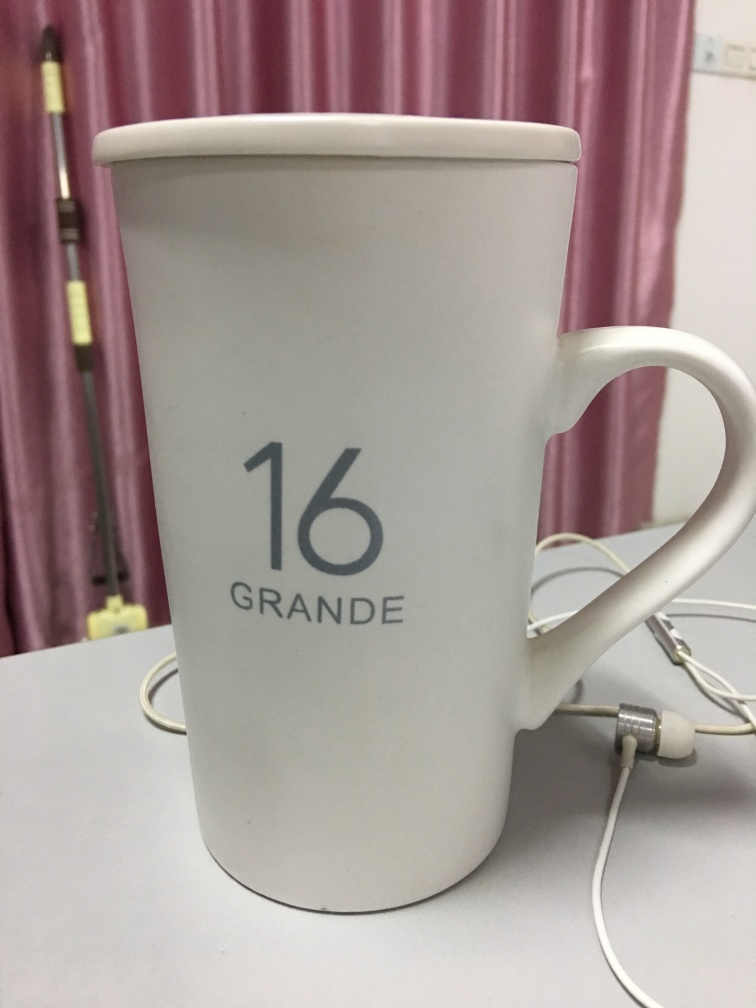Does this image suggest a particular use for the mug other than drinking? Interestingly, yes. The mug in the picture is currently being used to hold a pair of earphones, which is a creative way to prevent the cords from becoming tangled. This repurposing signifies the versatility of such common objects and how they can be adapted to serve secondary functions other than their intended use. Can you guess the capacity of this mug? Given the text 'GRANDE' which often signifies a large size at coffee shops, and the number '16', it's reasonable to infer that the mug could hold approximately 16 ounces of liquid, which aligns with what is typically considered a grande size. 